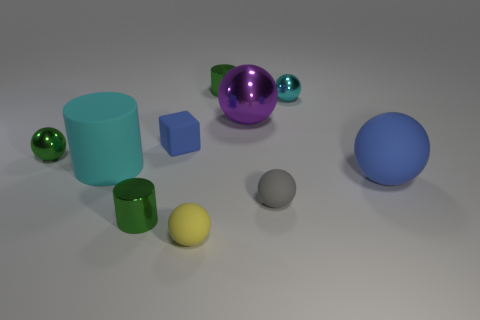Subtract all green cylinders. How many cylinders are left? 1 Subtract all blue spheres. How many spheres are left? 5 Subtract all cylinders. How many objects are left? 7 Subtract 1 spheres. How many spheres are left? 5 Subtract all green balls. How many cyan cylinders are left? 1 Subtract all metallic balls. Subtract all yellow things. How many objects are left? 6 Add 1 green shiny balls. How many green shiny balls are left? 2 Add 9 tiny cyan shiny things. How many tiny cyan shiny things exist? 10 Subtract 0 yellow cylinders. How many objects are left? 10 Subtract all brown cubes. Subtract all gray balls. How many cubes are left? 1 